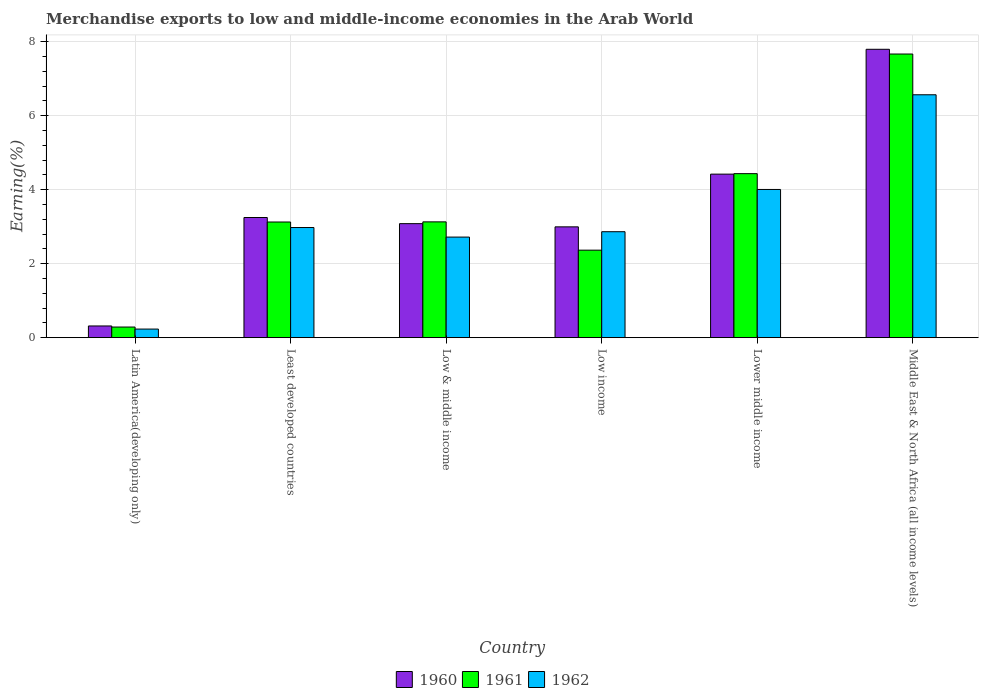How many different coloured bars are there?
Make the answer very short. 3. How many groups of bars are there?
Give a very brief answer. 6. Are the number of bars per tick equal to the number of legend labels?
Your answer should be very brief. Yes. What is the label of the 6th group of bars from the left?
Provide a succinct answer. Middle East & North Africa (all income levels). What is the percentage of amount earned from merchandise exports in 1962 in Least developed countries?
Make the answer very short. 2.98. Across all countries, what is the maximum percentage of amount earned from merchandise exports in 1960?
Keep it short and to the point. 7.8. Across all countries, what is the minimum percentage of amount earned from merchandise exports in 1962?
Your response must be concise. 0.23. In which country was the percentage of amount earned from merchandise exports in 1962 maximum?
Provide a short and direct response. Middle East & North Africa (all income levels). In which country was the percentage of amount earned from merchandise exports in 1962 minimum?
Keep it short and to the point. Latin America(developing only). What is the total percentage of amount earned from merchandise exports in 1961 in the graph?
Your answer should be very brief. 21.02. What is the difference between the percentage of amount earned from merchandise exports in 1960 in Least developed countries and that in Low & middle income?
Keep it short and to the point. 0.17. What is the difference between the percentage of amount earned from merchandise exports in 1960 in Low income and the percentage of amount earned from merchandise exports in 1962 in Middle East & North Africa (all income levels)?
Make the answer very short. -3.57. What is the average percentage of amount earned from merchandise exports in 1960 per country?
Your response must be concise. 3.64. What is the difference between the percentage of amount earned from merchandise exports of/in 1961 and percentage of amount earned from merchandise exports of/in 1960 in Low & middle income?
Offer a terse response. 0.05. In how many countries, is the percentage of amount earned from merchandise exports in 1960 greater than 2.4 %?
Provide a short and direct response. 5. What is the ratio of the percentage of amount earned from merchandise exports in 1962 in Least developed countries to that in Middle East & North Africa (all income levels)?
Offer a terse response. 0.45. Is the difference between the percentage of amount earned from merchandise exports in 1961 in Latin America(developing only) and Low income greater than the difference between the percentage of amount earned from merchandise exports in 1960 in Latin America(developing only) and Low income?
Ensure brevity in your answer.  Yes. What is the difference between the highest and the second highest percentage of amount earned from merchandise exports in 1962?
Make the answer very short. -1.03. What is the difference between the highest and the lowest percentage of amount earned from merchandise exports in 1962?
Ensure brevity in your answer.  6.34. In how many countries, is the percentage of amount earned from merchandise exports in 1962 greater than the average percentage of amount earned from merchandise exports in 1962 taken over all countries?
Offer a very short reply. 2. Is the sum of the percentage of amount earned from merchandise exports in 1962 in Low income and Middle East & North Africa (all income levels) greater than the maximum percentage of amount earned from merchandise exports in 1961 across all countries?
Keep it short and to the point. Yes. What does the 1st bar from the left in Low & middle income represents?
Your response must be concise. 1960. What does the 1st bar from the right in Low income represents?
Offer a terse response. 1962. Is it the case that in every country, the sum of the percentage of amount earned from merchandise exports in 1961 and percentage of amount earned from merchandise exports in 1960 is greater than the percentage of amount earned from merchandise exports in 1962?
Provide a succinct answer. Yes. Are all the bars in the graph horizontal?
Your answer should be very brief. No. How many countries are there in the graph?
Provide a short and direct response. 6. What is the difference between two consecutive major ticks on the Y-axis?
Keep it short and to the point. 2. Where does the legend appear in the graph?
Your answer should be compact. Bottom center. How are the legend labels stacked?
Offer a very short reply. Horizontal. What is the title of the graph?
Make the answer very short. Merchandise exports to low and middle-income economies in the Arab World. Does "2015" appear as one of the legend labels in the graph?
Provide a succinct answer. No. What is the label or title of the Y-axis?
Make the answer very short. Earning(%). What is the Earning(%) in 1960 in Latin America(developing only)?
Keep it short and to the point. 0.32. What is the Earning(%) of 1961 in Latin America(developing only)?
Your answer should be very brief. 0.29. What is the Earning(%) of 1962 in Latin America(developing only)?
Give a very brief answer. 0.23. What is the Earning(%) of 1960 in Least developed countries?
Your answer should be very brief. 3.25. What is the Earning(%) in 1961 in Least developed countries?
Offer a very short reply. 3.13. What is the Earning(%) in 1962 in Least developed countries?
Offer a terse response. 2.98. What is the Earning(%) in 1960 in Low & middle income?
Provide a short and direct response. 3.08. What is the Earning(%) of 1961 in Low & middle income?
Offer a very short reply. 3.13. What is the Earning(%) in 1962 in Low & middle income?
Ensure brevity in your answer.  2.72. What is the Earning(%) in 1960 in Low income?
Offer a terse response. 3. What is the Earning(%) of 1961 in Low income?
Your answer should be very brief. 2.37. What is the Earning(%) in 1962 in Low income?
Ensure brevity in your answer.  2.86. What is the Earning(%) of 1960 in Lower middle income?
Your answer should be compact. 4.42. What is the Earning(%) of 1961 in Lower middle income?
Make the answer very short. 4.43. What is the Earning(%) in 1962 in Lower middle income?
Offer a terse response. 4.01. What is the Earning(%) of 1960 in Middle East & North Africa (all income levels)?
Ensure brevity in your answer.  7.8. What is the Earning(%) of 1961 in Middle East & North Africa (all income levels)?
Give a very brief answer. 7.67. What is the Earning(%) in 1962 in Middle East & North Africa (all income levels)?
Your answer should be very brief. 6.57. Across all countries, what is the maximum Earning(%) in 1960?
Give a very brief answer. 7.8. Across all countries, what is the maximum Earning(%) of 1961?
Offer a terse response. 7.67. Across all countries, what is the maximum Earning(%) of 1962?
Offer a very short reply. 6.57. Across all countries, what is the minimum Earning(%) of 1960?
Your answer should be compact. 0.32. Across all countries, what is the minimum Earning(%) of 1961?
Ensure brevity in your answer.  0.29. Across all countries, what is the minimum Earning(%) in 1962?
Make the answer very short. 0.23. What is the total Earning(%) of 1960 in the graph?
Offer a very short reply. 21.86. What is the total Earning(%) in 1961 in the graph?
Give a very brief answer. 21.02. What is the total Earning(%) of 1962 in the graph?
Your answer should be very brief. 19.37. What is the difference between the Earning(%) in 1960 in Latin America(developing only) and that in Least developed countries?
Give a very brief answer. -2.93. What is the difference between the Earning(%) in 1961 in Latin America(developing only) and that in Least developed countries?
Make the answer very short. -2.84. What is the difference between the Earning(%) in 1962 in Latin America(developing only) and that in Least developed countries?
Keep it short and to the point. -2.75. What is the difference between the Earning(%) of 1960 in Latin America(developing only) and that in Low & middle income?
Make the answer very short. -2.77. What is the difference between the Earning(%) in 1961 in Latin America(developing only) and that in Low & middle income?
Provide a short and direct response. -2.84. What is the difference between the Earning(%) in 1962 in Latin America(developing only) and that in Low & middle income?
Your response must be concise. -2.49. What is the difference between the Earning(%) in 1960 in Latin America(developing only) and that in Low income?
Give a very brief answer. -2.68. What is the difference between the Earning(%) in 1961 in Latin America(developing only) and that in Low income?
Offer a terse response. -2.08. What is the difference between the Earning(%) in 1962 in Latin America(developing only) and that in Low income?
Provide a succinct answer. -2.63. What is the difference between the Earning(%) of 1960 in Latin America(developing only) and that in Lower middle income?
Your response must be concise. -4.11. What is the difference between the Earning(%) of 1961 in Latin America(developing only) and that in Lower middle income?
Make the answer very short. -4.15. What is the difference between the Earning(%) of 1962 in Latin America(developing only) and that in Lower middle income?
Your answer should be very brief. -3.78. What is the difference between the Earning(%) of 1960 in Latin America(developing only) and that in Middle East & North Africa (all income levels)?
Your response must be concise. -7.48. What is the difference between the Earning(%) of 1961 in Latin America(developing only) and that in Middle East & North Africa (all income levels)?
Provide a short and direct response. -7.38. What is the difference between the Earning(%) in 1962 in Latin America(developing only) and that in Middle East & North Africa (all income levels)?
Your response must be concise. -6.34. What is the difference between the Earning(%) of 1960 in Least developed countries and that in Low & middle income?
Ensure brevity in your answer.  0.17. What is the difference between the Earning(%) of 1961 in Least developed countries and that in Low & middle income?
Provide a short and direct response. -0. What is the difference between the Earning(%) in 1962 in Least developed countries and that in Low & middle income?
Provide a short and direct response. 0.26. What is the difference between the Earning(%) of 1960 in Least developed countries and that in Low income?
Provide a short and direct response. 0.25. What is the difference between the Earning(%) in 1961 in Least developed countries and that in Low income?
Give a very brief answer. 0.76. What is the difference between the Earning(%) of 1962 in Least developed countries and that in Low income?
Your answer should be very brief. 0.11. What is the difference between the Earning(%) in 1960 in Least developed countries and that in Lower middle income?
Offer a very short reply. -1.17. What is the difference between the Earning(%) of 1961 in Least developed countries and that in Lower middle income?
Keep it short and to the point. -1.31. What is the difference between the Earning(%) of 1962 in Least developed countries and that in Lower middle income?
Provide a short and direct response. -1.03. What is the difference between the Earning(%) of 1960 in Least developed countries and that in Middle East & North Africa (all income levels)?
Your answer should be very brief. -4.55. What is the difference between the Earning(%) in 1961 in Least developed countries and that in Middle East & North Africa (all income levels)?
Make the answer very short. -4.54. What is the difference between the Earning(%) in 1962 in Least developed countries and that in Middle East & North Africa (all income levels)?
Provide a short and direct response. -3.59. What is the difference between the Earning(%) of 1960 in Low & middle income and that in Low income?
Give a very brief answer. 0.09. What is the difference between the Earning(%) in 1961 in Low & middle income and that in Low income?
Offer a very short reply. 0.77. What is the difference between the Earning(%) of 1962 in Low & middle income and that in Low income?
Your answer should be compact. -0.14. What is the difference between the Earning(%) in 1960 in Low & middle income and that in Lower middle income?
Offer a very short reply. -1.34. What is the difference between the Earning(%) of 1961 in Low & middle income and that in Lower middle income?
Keep it short and to the point. -1.3. What is the difference between the Earning(%) in 1962 in Low & middle income and that in Lower middle income?
Offer a very short reply. -1.29. What is the difference between the Earning(%) of 1960 in Low & middle income and that in Middle East & North Africa (all income levels)?
Give a very brief answer. -4.71. What is the difference between the Earning(%) of 1961 in Low & middle income and that in Middle East & North Africa (all income levels)?
Give a very brief answer. -4.54. What is the difference between the Earning(%) of 1962 in Low & middle income and that in Middle East & North Africa (all income levels)?
Your response must be concise. -3.85. What is the difference between the Earning(%) in 1960 in Low income and that in Lower middle income?
Your answer should be very brief. -1.43. What is the difference between the Earning(%) of 1961 in Low income and that in Lower middle income?
Ensure brevity in your answer.  -2.07. What is the difference between the Earning(%) of 1962 in Low income and that in Lower middle income?
Provide a succinct answer. -1.14. What is the difference between the Earning(%) in 1960 in Low income and that in Middle East & North Africa (all income levels)?
Ensure brevity in your answer.  -4.8. What is the difference between the Earning(%) in 1961 in Low income and that in Middle East & North Africa (all income levels)?
Your answer should be very brief. -5.3. What is the difference between the Earning(%) in 1962 in Low income and that in Middle East & North Africa (all income levels)?
Ensure brevity in your answer.  -3.7. What is the difference between the Earning(%) of 1960 in Lower middle income and that in Middle East & North Africa (all income levels)?
Keep it short and to the point. -3.38. What is the difference between the Earning(%) in 1961 in Lower middle income and that in Middle East & North Africa (all income levels)?
Keep it short and to the point. -3.23. What is the difference between the Earning(%) in 1962 in Lower middle income and that in Middle East & North Africa (all income levels)?
Offer a terse response. -2.56. What is the difference between the Earning(%) in 1960 in Latin America(developing only) and the Earning(%) in 1961 in Least developed countries?
Your response must be concise. -2.81. What is the difference between the Earning(%) in 1960 in Latin America(developing only) and the Earning(%) in 1962 in Least developed countries?
Offer a very short reply. -2.66. What is the difference between the Earning(%) in 1961 in Latin America(developing only) and the Earning(%) in 1962 in Least developed countries?
Offer a terse response. -2.69. What is the difference between the Earning(%) of 1960 in Latin America(developing only) and the Earning(%) of 1961 in Low & middle income?
Keep it short and to the point. -2.81. What is the difference between the Earning(%) of 1960 in Latin America(developing only) and the Earning(%) of 1962 in Low & middle income?
Your answer should be compact. -2.4. What is the difference between the Earning(%) in 1961 in Latin America(developing only) and the Earning(%) in 1962 in Low & middle income?
Provide a succinct answer. -2.43. What is the difference between the Earning(%) in 1960 in Latin America(developing only) and the Earning(%) in 1961 in Low income?
Provide a short and direct response. -2.05. What is the difference between the Earning(%) in 1960 in Latin America(developing only) and the Earning(%) in 1962 in Low income?
Offer a terse response. -2.55. What is the difference between the Earning(%) of 1961 in Latin America(developing only) and the Earning(%) of 1962 in Low income?
Provide a short and direct response. -2.58. What is the difference between the Earning(%) in 1960 in Latin America(developing only) and the Earning(%) in 1961 in Lower middle income?
Offer a terse response. -4.12. What is the difference between the Earning(%) in 1960 in Latin America(developing only) and the Earning(%) in 1962 in Lower middle income?
Make the answer very short. -3.69. What is the difference between the Earning(%) of 1961 in Latin America(developing only) and the Earning(%) of 1962 in Lower middle income?
Your response must be concise. -3.72. What is the difference between the Earning(%) of 1960 in Latin America(developing only) and the Earning(%) of 1961 in Middle East & North Africa (all income levels)?
Your response must be concise. -7.35. What is the difference between the Earning(%) in 1960 in Latin America(developing only) and the Earning(%) in 1962 in Middle East & North Africa (all income levels)?
Give a very brief answer. -6.25. What is the difference between the Earning(%) of 1961 in Latin America(developing only) and the Earning(%) of 1962 in Middle East & North Africa (all income levels)?
Ensure brevity in your answer.  -6.28. What is the difference between the Earning(%) in 1960 in Least developed countries and the Earning(%) in 1961 in Low & middle income?
Your answer should be very brief. 0.12. What is the difference between the Earning(%) of 1960 in Least developed countries and the Earning(%) of 1962 in Low & middle income?
Provide a succinct answer. 0.53. What is the difference between the Earning(%) of 1961 in Least developed countries and the Earning(%) of 1962 in Low & middle income?
Provide a short and direct response. 0.41. What is the difference between the Earning(%) in 1960 in Least developed countries and the Earning(%) in 1961 in Low income?
Offer a terse response. 0.88. What is the difference between the Earning(%) of 1960 in Least developed countries and the Earning(%) of 1962 in Low income?
Give a very brief answer. 0.38. What is the difference between the Earning(%) of 1961 in Least developed countries and the Earning(%) of 1962 in Low income?
Give a very brief answer. 0.26. What is the difference between the Earning(%) of 1960 in Least developed countries and the Earning(%) of 1961 in Lower middle income?
Ensure brevity in your answer.  -1.19. What is the difference between the Earning(%) of 1960 in Least developed countries and the Earning(%) of 1962 in Lower middle income?
Make the answer very short. -0.76. What is the difference between the Earning(%) of 1961 in Least developed countries and the Earning(%) of 1962 in Lower middle income?
Your answer should be very brief. -0.88. What is the difference between the Earning(%) of 1960 in Least developed countries and the Earning(%) of 1961 in Middle East & North Africa (all income levels)?
Your answer should be very brief. -4.42. What is the difference between the Earning(%) of 1960 in Least developed countries and the Earning(%) of 1962 in Middle East & North Africa (all income levels)?
Provide a short and direct response. -3.32. What is the difference between the Earning(%) of 1961 in Least developed countries and the Earning(%) of 1962 in Middle East & North Africa (all income levels)?
Make the answer very short. -3.44. What is the difference between the Earning(%) of 1960 in Low & middle income and the Earning(%) of 1961 in Low income?
Provide a short and direct response. 0.72. What is the difference between the Earning(%) of 1960 in Low & middle income and the Earning(%) of 1962 in Low income?
Give a very brief answer. 0.22. What is the difference between the Earning(%) of 1961 in Low & middle income and the Earning(%) of 1962 in Low income?
Ensure brevity in your answer.  0.27. What is the difference between the Earning(%) in 1960 in Low & middle income and the Earning(%) in 1961 in Lower middle income?
Make the answer very short. -1.35. What is the difference between the Earning(%) in 1960 in Low & middle income and the Earning(%) in 1962 in Lower middle income?
Your answer should be compact. -0.92. What is the difference between the Earning(%) of 1961 in Low & middle income and the Earning(%) of 1962 in Lower middle income?
Keep it short and to the point. -0.88. What is the difference between the Earning(%) in 1960 in Low & middle income and the Earning(%) in 1961 in Middle East & North Africa (all income levels)?
Provide a succinct answer. -4.59. What is the difference between the Earning(%) of 1960 in Low & middle income and the Earning(%) of 1962 in Middle East & North Africa (all income levels)?
Offer a terse response. -3.48. What is the difference between the Earning(%) of 1961 in Low & middle income and the Earning(%) of 1962 in Middle East & North Africa (all income levels)?
Keep it short and to the point. -3.44. What is the difference between the Earning(%) in 1960 in Low income and the Earning(%) in 1961 in Lower middle income?
Your answer should be very brief. -1.44. What is the difference between the Earning(%) in 1960 in Low income and the Earning(%) in 1962 in Lower middle income?
Your answer should be compact. -1.01. What is the difference between the Earning(%) of 1961 in Low income and the Earning(%) of 1962 in Lower middle income?
Give a very brief answer. -1.64. What is the difference between the Earning(%) in 1960 in Low income and the Earning(%) in 1961 in Middle East & North Africa (all income levels)?
Keep it short and to the point. -4.67. What is the difference between the Earning(%) of 1960 in Low income and the Earning(%) of 1962 in Middle East & North Africa (all income levels)?
Offer a terse response. -3.57. What is the difference between the Earning(%) in 1961 in Low income and the Earning(%) in 1962 in Middle East & North Africa (all income levels)?
Provide a short and direct response. -4.2. What is the difference between the Earning(%) in 1960 in Lower middle income and the Earning(%) in 1961 in Middle East & North Africa (all income levels)?
Ensure brevity in your answer.  -3.25. What is the difference between the Earning(%) of 1960 in Lower middle income and the Earning(%) of 1962 in Middle East & North Africa (all income levels)?
Provide a succinct answer. -2.15. What is the difference between the Earning(%) of 1961 in Lower middle income and the Earning(%) of 1962 in Middle East & North Africa (all income levels)?
Give a very brief answer. -2.13. What is the average Earning(%) of 1960 per country?
Give a very brief answer. 3.64. What is the average Earning(%) in 1961 per country?
Make the answer very short. 3.5. What is the average Earning(%) in 1962 per country?
Your answer should be very brief. 3.23. What is the difference between the Earning(%) in 1960 and Earning(%) in 1961 in Latin America(developing only)?
Your answer should be compact. 0.03. What is the difference between the Earning(%) in 1960 and Earning(%) in 1962 in Latin America(developing only)?
Your response must be concise. 0.08. What is the difference between the Earning(%) in 1961 and Earning(%) in 1962 in Latin America(developing only)?
Make the answer very short. 0.06. What is the difference between the Earning(%) of 1960 and Earning(%) of 1961 in Least developed countries?
Keep it short and to the point. 0.12. What is the difference between the Earning(%) of 1960 and Earning(%) of 1962 in Least developed countries?
Provide a succinct answer. 0.27. What is the difference between the Earning(%) in 1961 and Earning(%) in 1962 in Least developed countries?
Provide a short and direct response. 0.15. What is the difference between the Earning(%) in 1960 and Earning(%) in 1961 in Low & middle income?
Keep it short and to the point. -0.05. What is the difference between the Earning(%) of 1960 and Earning(%) of 1962 in Low & middle income?
Keep it short and to the point. 0.36. What is the difference between the Earning(%) in 1961 and Earning(%) in 1962 in Low & middle income?
Ensure brevity in your answer.  0.41. What is the difference between the Earning(%) in 1960 and Earning(%) in 1961 in Low income?
Keep it short and to the point. 0.63. What is the difference between the Earning(%) in 1960 and Earning(%) in 1962 in Low income?
Ensure brevity in your answer.  0.13. What is the difference between the Earning(%) of 1961 and Earning(%) of 1962 in Low income?
Keep it short and to the point. -0.5. What is the difference between the Earning(%) in 1960 and Earning(%) in 1961 in Lower middle income?
Keep it short and to the point. -0.01. What is the difference between the Earning(%) in 1960 and Earning(%) in 1962 in Lower middle income?
Keep it short and to the point. 0.41. What is the difference between the Earning(%) of 1961 and Earning(%) of 1962 in Lower middle income?
Ensure brevity in your answer.  0.43. What is the difference between the Earning(%) in 1960 and Earning(%) in 1961 in Middle East & North Africa (all income levels)?
Offer a very short reply. 0.13. What is the difference between the Earning(%) of 1960 and Earning(%) of 1962 in Middle East & North Africa (all income levels)?
Keep it short and to the point. 1.23. What is the difference between the Earning(%) of 1961 and Earning(%) of 1962 in Middle East & North Africa (all income levels)?
Offer a very short reply. 1.1. What is the ratio of the Earning(%) in 1960 in Latin America(developing only) to that in Least developed countries?
Give a very brief answer. 0.1. What is the ratio of the Earning(%) of 1961 in Latin America(developing only) to that in Least developed countries?
Your answer should be very brief. 0.09. What is the ratio of the Earning(%) of 1962 in Latin America(developing only) to that in Least developed countries?
Ensure brevity in your answer.  0.08. What is the ratio of the Earning(%) of 1960 in Latin America(developing only) to that in Low & middle income?
Your answer should be compact. 0.1. What is the ratio of the Earning(%) of 1961 in Latin America(developing only) to that in Low & middle income?
Provide a short and direct response. 0.09. What is the ratio of the Earning(%) of 1962 in Latin America(developing only) to that in Low & middle income?
Provide a succinct answer. 0.09. What is the ratio of the Earning(%) in 1960 in Latin America(developing only) to that in Low income?
Keep it short and to the point. 0.11. What is the ratio of the Earning(%) in 1961 in Latin America(developing only) to that in Low income?
Offer a very short reply. 0.12. What is the ratio of the Earning(%) in 1962 in Latin America(developing only) to that in Low income?
Offer a terse response. 0.08. What is the ratio of the Earning(%) in 1960 in Latin America(developing only) to that in Lower middle income?
Provide a succinct answer. 0.07. What is the ratio of the Earning(%) in 1961 in Latin America(developing only) to that in Lower middle income?
Offer a terse response. 0.06. What is the ratio of the Earning(%) in 1962 in Latin America(developing only) to that in Lower middle income?
Ensure brevity in your answer.  0.06. What is the ratio of the Earning(%) of 1960 in Latin America(developing only) to that in Middle East & North Africa (all income levels)?
Keep it short and to the point. 0.04. What is the ratio of the Earning(%) of 1961 in Latin America(developing only) to that in Middle East & North Africa (all income levels)?
Offer a terse response. 0.04. What is the ratio of the Earning(%) of 1962 in Latin America(developing only) to that in Middle East & North Africa (all income levels)?
Offer a very short reply. 0.04. What is the ratio of the Earning(%) of 1960 in Least developed countries to that in Low & middle income?
Make the answer very short. 1.05. What is the ratio of the Earning(%) in 1962 in Least developed countries to that in Low & middle income?
Provide a succinct answer. 1.09. What is the ratio of the Earning(%) in 1960 in Least developed countries to that in Low income?
Your answer should be very brief. 1.08. What is the ratio of the Earning(%) of 1961 in Least developed countries to that in Low income?
Ensure brevity in your answer.  1.32. What is the ratio of the Earning(%) of 1962 in Least developed countries to that in Low income?
Offer a very short reply. 1.04. What is the ratio of the Earning(%) of 1960 in Least developed countries to that in Lower middle income?
Offer a very short reply. 0.73. What is the ratio of the Earning(%) in 1961 in Least developed countries to that in Lower middle income?
Give a very brief answer. 0.71. What is the ratio of the Earning(%) in 1962 in Least developed countries to that in Lower middle income?
Keep it short and to the point. 0.74. What is the ratio of the Earning(%) in 1960 in Least developed countries to that in Middle East & North Africa (all income levels)?
Offer a very short reply. 0.42. What is the ratio of the Earning(%) in 1961 in Least developed countries to that in Middle East & North Africa (all income levels)?
Give a very brief answer. 0.41. What is the ratio of the Earning(%) in 1962 in Least developed countries to that in Middle East & North Africa (all income levels)?
Ensure brevity in your answer.  0.45. What is the ratio of the Earning(%) in 1960 in Low & middle income to that in Low income?
Offer a very short reply. 1.03. What is the ratio of the Earning(%) in 1961 in Low & middle income to that in Low income?
Give a very brief answer. 1.32. What is the ratio of the Earning(%) in 1962 in Low & middle income to that in Low income?
Your answer should be very brief. 0.95. What is the ratio of the Earning(%) in 1960 in Low & middle income to that in Lower middle income?
Make the answer very short. 0.7. What is the ratio of the Earning(%) of 1961 in Low & middle income to that in Lower middle income?
Make the answer very short. 0.71. What is the ratio of the Earning(%) in 1962 in Low & middle income to that in Lower middle income?
Provide a short and direct response. 0.68. What is the ratio of the Earning(%) in 1960 in Low & middle income to that in Middle East & North Africa (all income levels)?
Your response must be concise. 0.4. What is the ratio of the Earning(%) in 1961 in Low & middle income to that in Middle East & North Africa (all income levels)?
Make the answer very short. 0.41. What is the ratio of the Earning(%) in 1962 in Low & middle income to that in Middle East & North Africa (all income levels)?
Your answer should be very brief. 0.41. What is the ratio of the Earning(%) in 1960 in Low income to that in Lower middle income?
Make the answer very short. 0.68. What is the ratio of the Earning(%) of 1961 in Low income to that in Lower middle income?
Give a very brief answer. 0.53. What is the ratio of the Earning(%) of 1962 in Low income to that in Lower middle income?
Offer a very short reply. 0.71. What is the ratio of the Earning(%) in 1960 in Low income to that in Middle East & North Africa (all income levels)?
Keep it short and to the point. 0.38. What is the ratio of the Earning(%) of 1961 in Low income to that in Middle East & North Africa (all income levels)?
Provide a succinct answer. 0.31. What is the ratio of the Earning(%) of 1962 in Low income to that in Middle East & North Africa (all income levels)?
Your answer should be compact. 0.44. What is the ratio of the Earning(%) in 1960 in Lower middle income to that in Middle East & North Africa (all income levels)?
Offer a very short reply. 0.57. What is the ratio of the Earning(%) in 1961 in Lower middle income to that in Middle East & North Africa (all income levels)?
Keep it short and to the point. 0.58. What is the ratio of the Earning(%) of 1962 in Lower middle income to that in Middle East & North Africa (all income levels)?
Ensure brevity in your answer.  0.61. What is the difference between the highest and the second highest Earning(%) in 1960?
Make the answer very short. 3.38. What is the difference between the highest and the second highest Earning(%) in 1961?
Provide a succinct answer. 3.23. What is the difference between the highest and the second highest Earning(%) of 1962?
Provide a short and direct response. 2.56. What is the difference between the highest and the lowest Earning(%) of 1960?
Your response must be concise. 7.48. What is the difference between the highest and the lowest Earning(%) of 1961?
Offer a very short reply. 7.38. What is the difference between the highest and the lowest Earning(%) of 1962?
Your answer should be compact. 6.34. 